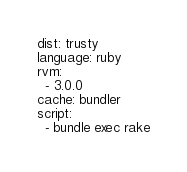Convert code to text. <code><loc_0><loc_0><loc_500><loc_500><_YAML_>dist: trusty
language: ruby
rvm:
  - 3.0.0
cache: bundler
script:
  - bundle exec rake
</code> 